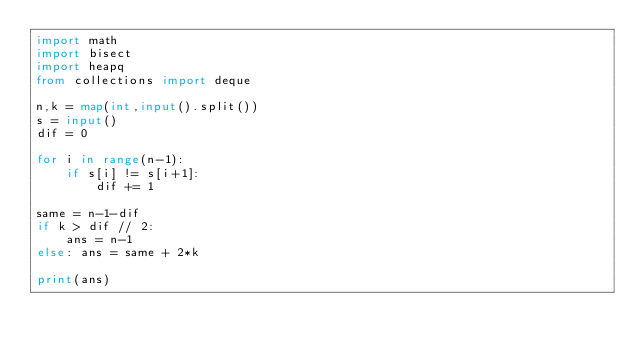Convert code to text. <code><loc_0><loc_0><loc_500><loc_500><_Python_>import math 
import bisect
import heapq
from collections import deque

n,k = map(int,input().split())
s = input()
dif = 0

for i in range(n-1):
    if s[i] != s[i+1]:
        dif += 1

same = n-1-dif
if k > dif // 2:
    ans = n-1
else: ans = same + 2*k

print(ans)</code> 